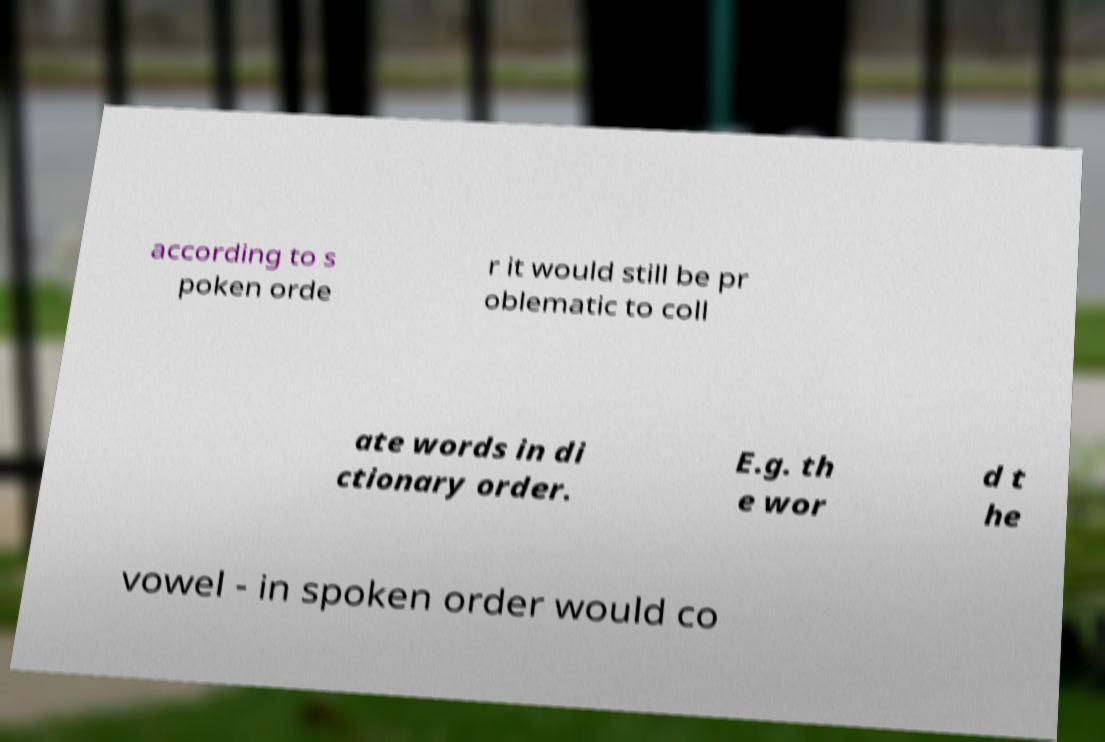For documentation purposes, I need the text within this image transcribed. Could you provide that? according to s poken orde r it would still be pr oblematic to coll ate words in di ctionary order. E.g. th e wor d t he vowel - in spoken order would co 